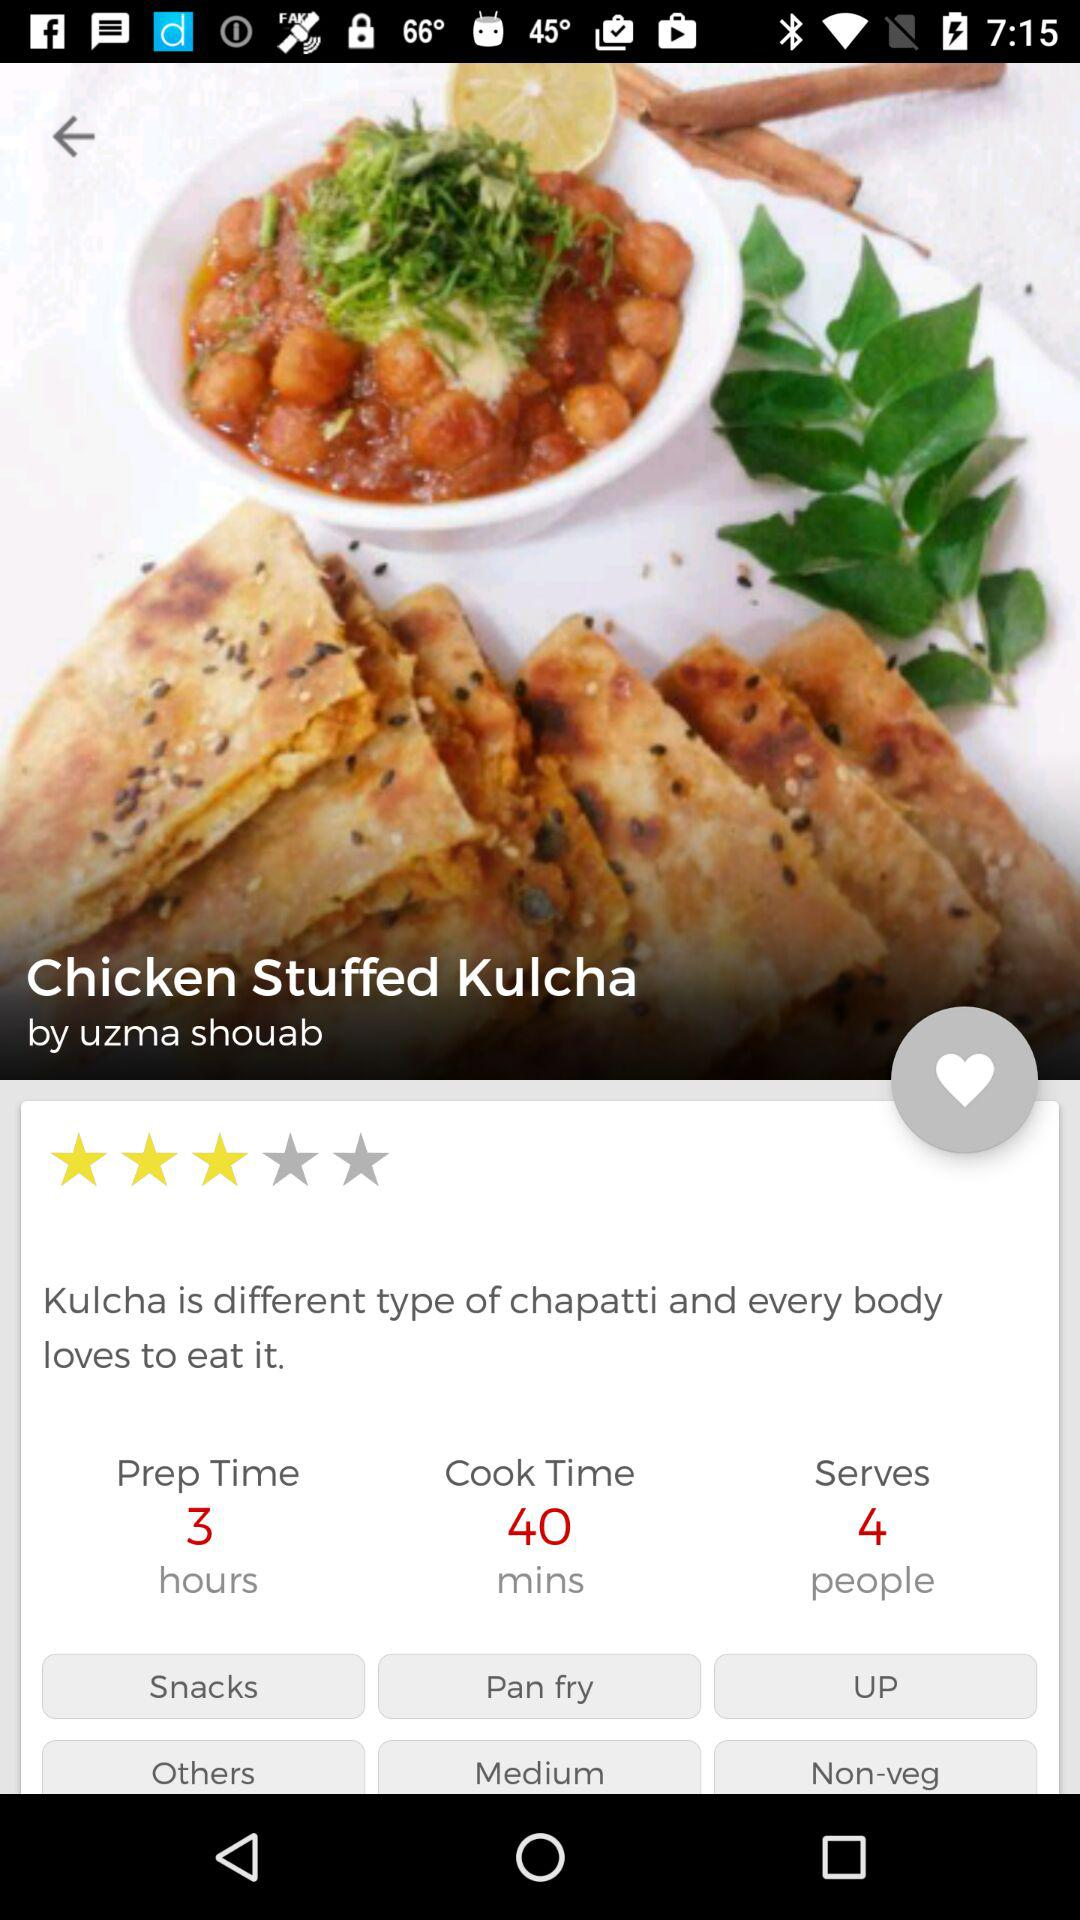What kind of meal category does this dish fall into, and is it suitable for vegetarians? This dish is categorized as 'Non-veg' and 'Snacks' as per the image, indicating it contains meat and is not suitable for vegetarians, but is likely enjoyed as a hearty snack or a light meal. Could you suggest a beverage that would pair well with this dish? A refreshing mint yogurt drink or a sweet mango lassi would complement the flavors of the Chicken Stuffed Kulcha nicely. 